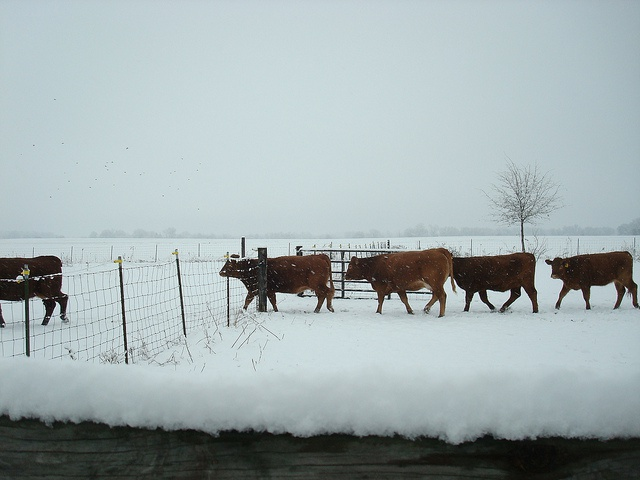Describe the objects in this image and their specific colors. I can see cow in lightgray, maroon, black, and gray tones, cow in lightgray, black, maroon, and gray tones, cow in lightgray, black, maroon, and gray tones, cow in lightgray, black, gray, and darkgray tones, and cow in lightgray, black, gray, and darkgray tones in this image. 